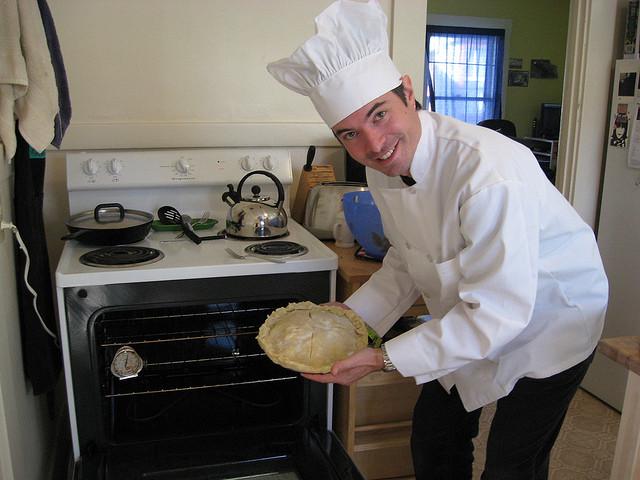Is he a professional?
Quick response, please. Yes. What is the chef putting in the oven?
Give a very brief answer. Pie. How many chefs are in the kitchen?
Concise answer only. 1. Is the chef happy?
Give a very brief answer. Yes. 